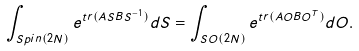<formula> <loc_0><loc_0><loc_500><loc_500>\int _ { S p i n ( 2 N ) } e ^ { t r ( A S B S ^ { - 1 } ) } d S = \int _ { S O ( 2 N ) } e ^ { t r ( A O B O ^ { T } ) } d O .</formula> 